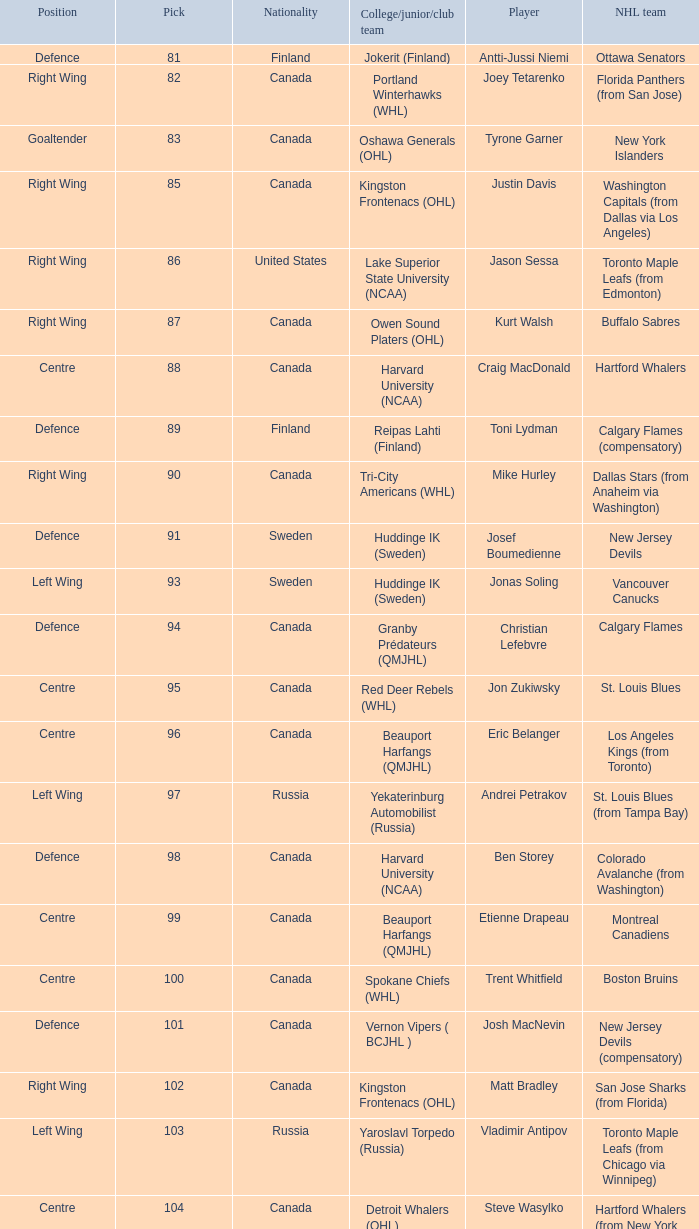How many players came from college team reipas lahti (finland)? 1.0. 